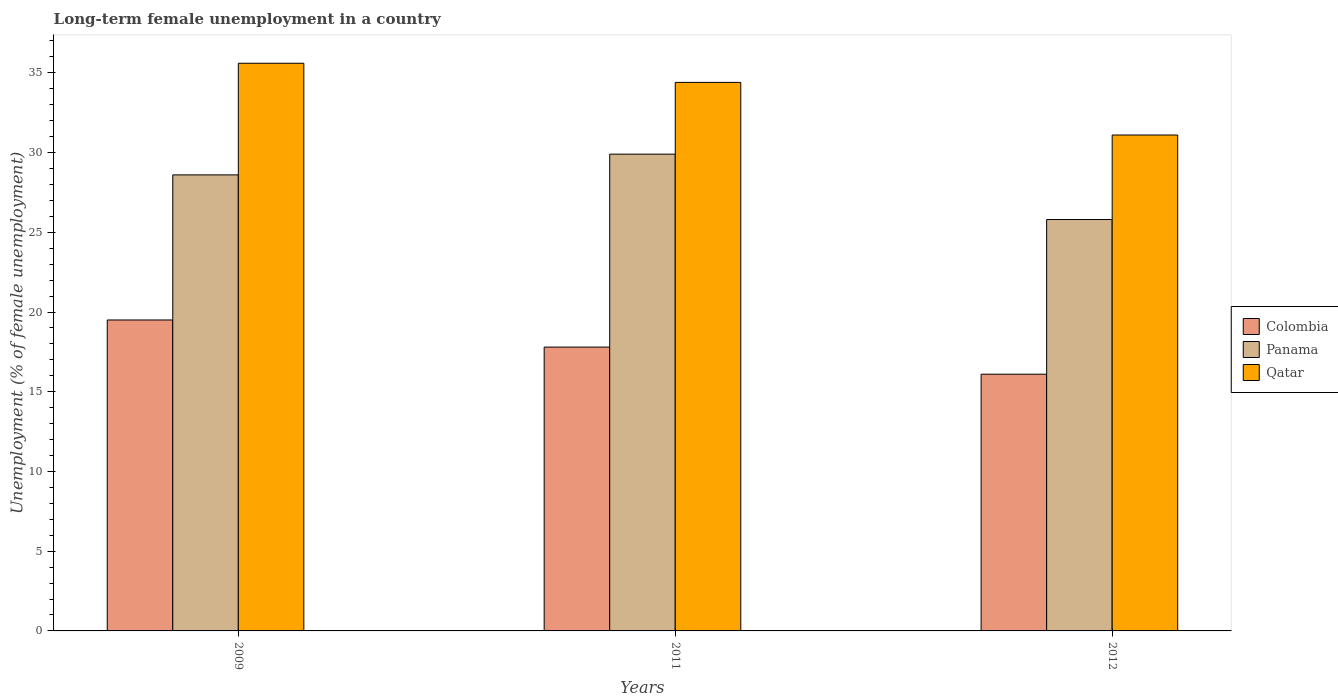How many different coloured bars are there?
Your answer should be compact. 3. How many bars are there on the 2nd tick from the left?
Offer a very short reply. 3. What is the label of the 1st group of bars from the left?
Your answer should be very brief. 2009. What is the percentage of long-term unemployed female population in Colombia in 2011?
Provide a succinct answer. 17.8. Across all years, what is the minimum percentage of long-term unemployed female population in Panama?
Your answer should be very brief. 25.8. In which year was the percentage of long-term unemployed female population in Qatar maximum?
Your response must be concise. 2009. In which year was the percentage of long-term unemployed female population in Panama minimum?
Provide a short and direct response. 2012. What is the total percentage of long-term unemployed female population in Colombia in the graph?
Offer a terse response. 53.4. What is the difference between the percentage of long-term unemployed female population in Qatar in 2009 and that in 2011?
Provide a short and direct response. 1.2. What is the average percentage of long-term unemployed female population in Colombia per year?
Provide a short and direct response. 17.8. In the year 2012, what is the difference between the percentage of long-term unemployed female population in Colombia and percentage of long-term unemployed female population in Panama?
Your answer should be compact. -9.7. What is the ratio of the percentage of long-term unemployed female population in Qatar in 2011 to that in 2012?
Offer a terse response. 1.11. Is the difference between the percentage of long-term unemployed female population in Colombia in 2011 and 2012 greater than the difference between the percentage of long-term unemployed female population in Panama in 2011 and 2012?
Make the answer very short. No. What is the difference between the highest and the second highest percentage of long-term unemployed female population in Qatar?
Ensure brevity in your answer.  1.2. What is the difference between the highest and the lowest percentage of long-term unemployed female population in Colombia?
Make the answer very short. 3.4. Is the sum of the percentage of long-term unemployed female population in Qatar in 2009 and 2011 greater than the maximum percentage of long-term unemployed female population in Colombia across all years?
Give a very brief answer. Yes. What does the 1st bar from the left in 2009 represents?
Provide a short and direct response. Colombia. What does the 2nd bar from the right in 2012 represents?
Keep it short and to the point. Panama. Is it the case that in every year, the sum of the percentage of long-term unemployed female population in Panama and percentage of long-term unemployed female population in Qatar is greater than the percentage of long-term unemployed female population in Colombia?
Ensure brevity in your answer.  Yes. Are all the bars in the graph horizontal?
Ensure brevity in your answer.  No. How many years are there in the graph?
Give a very brief answer. 3. What is the difference between two consecutive major ticks on the Y-axis?
Make the answer very short. 5. Are the values on the major ticks of Y-axis written in scientific E-notation?
Offer a terse response. No. Where does the legend appear in the graph?
Offer a terse response. Center right. How many legend labels are there?
Make the answer very short. 3. How are the legend labels stacked?
Your response must be concise. Vertical. What is the title of the graph?
Your answer should be very brief. Long-term female unemployment in a country. What is the label or title of the X-axis?
Offer a very short reply. Years. What is the label or title of the Y-axis?
Your answer should be very brief. Unemployment (% of female unemployment). What is the Unemployment (% of female unemployment) in Colombia in 2009?
Provide a succinct answer. 19.5. What is the Unemployment (% of female unemployment) in Panama in 2009?
Provide a short and direct response. 28.6. What is the Unemployment (% of female unemployment) in Qatar in 2009?
Offer a very short reply. 35.6. What is the Unemployment (% of female unemployment) of Colombia in 2011?
Offer a very short reply. 17.8. What is the Unemployment (% of female unemployment) in Panama in 2011?
Keep it short and to the point. 29.9. What is the Unemployment (% of female unemployment) in Qatar in 2011?
Offer a very short reply. 34.4. What is the Unemployment (% of female unemployment) in Colombia in 2012?
Your response must be concise. 16.1. What is the Unemployment (% of female unemployment) of Panama in 2012?
Provide a short and direct response. 25.8. What is the Unemployment (% of female unemployment) in Qatar in 2012?
Your answer should be very brief. 31.1. Across all years, what is the maximum Unemployment (% of female unemployment) of Colombia?
Your answer should be very brief. 19.5. Across all years, what is the maximum Unemployment (% of female unemployment) in Panama?
Provide a short and direct response. 29.9. Across all years, what is the maximum Unemployment (% of female unemployment) in Qatar?
Ensure brevity in your answer.  35.6. Across all years, what is the minimum Unemployment (% of female unemployment) of Colombia?
Make the answer very short. 16.1. Across all years, what is the minimum Unemployment (% of female unemployment) in Panama?
Your answer should be very brief. 25.8. Across all years, what is the minimum Unemployment (% of female unemployment) of Qatar?
Provide a short and direct response. 31.1. What is the total Unemployment (% of female unemployment) of Colombia in the graph?
Ensure brevity in your answer.  53.4. What is the total Unemployment (% of female unemployment) in Panama in the graph?
Your response must be concise. 84.3. What is the total Unemployment (% of female unemployment) in Qatar in the graph?
Make the answer very short. 101.1. What is the difference between the Unemployment (% of female unemployment) of Colombia in 2009 and that in 2011?
Provide a succinct answer. 1.7. What is the difference between the Unemployment (% of female unemployment) of Panama in 2009 and that in 2011?
Your response must be concise. -1.3. What is the difference between the Unemployment (% of female unemployment) of Panama in 2009 and that in 2012?
Your response must be concise. 2.8. What is the difference between the Unemployment (% of female unemployment) in Qatar in 2009 and that in 2012?
Your response must be concise. 4.5. What is the difference between the Unemployment (% of female unemployment) in Colombia in 2011 and that in 2012?
Keep it short and to the point. 1.7. What is the difference between the Unemployment (% of female unemployment) in Panama in 2011 and that in 2012?
Your answer should be compact. 4.1. What is the difference between the Unemployment (% of female unemployment) in Colombia in 2009 and the Unemployment (% of female unemployment) in Qatar in 2011?
Provide a succinct answer. -14.9. What is the difference between the Unemployment (% of female unemployment) of Colombia in 2009 and the Unemployment (% of female unemployment) of Panama in 2012?
Give a very brief answer. -6.3. What is the difference between the Unemployment (% of female unemployment) of Colombia in 2011 and the Unemployment (% of female unemployment) of Panama in 2012?
Make the answer very short. -8. What is the difference between the Unemployment (% of female unemployment) of Panama in 2011 and the Unemployment (% of female unemployment) of Qatar in 2012?
Provide a short and direct response. -1.2. What is the average Unemployment (% of female unemployment) in Panama per year?
Ensure brevity in your answer.  28.1. What is the average Unemployment (% of female unemployment) of Qatar per year?
Provide a succinct answer. 33.7. In the year 2009, what is the difference between the Unemployment (% of female unemployment) in Colombia and Unemployment (% of female unemployment) in Qatar?
Your answer should be very brief. -16.1. In the year 2009, what is the difference between the Unemployment (% of female unemployment) of Panama and Unemployment (% of female unemployment) of Qatar?
Your answer should be compact. -7. In the year 2011, what is the difference between the Unemployment (% of female unemployment) in Colombia and Unemployment (% of female unemployment) in Panama?
Make the answer very short. -12.1. In the year 2011, what is the difference between the Unemployment (% of female unemployment) of Colombia and Unemployment (% of female unemployment) of Qatar?
Provide a short and direct response. -16.6. In the year 2011, what is the difference between the Unemployment (% of female unemployment) in Panama and Unemployment (% of female unemployment) in Qatar?
Provide a short and direct response. -4.5. What is the ratio of the Unemployment (% of female unemployment) of Colombia in 2009 to that in 2011?
Your answer should be very brief. 1.1. What is the ratio of the Unemployment (% of female unemployment) in Panama in 2009 to that in 2011?
Give a very brief answer. 0.96. What is the ratio of the Unemployment (% of female unemployment) in Qatar in 2009 to that in 2011?
Your answer should be very brief. 1.03. What is the ratio of the Unemployment (% of female unemployment) in Colombia in 2009 to that in 2012?
Make the answer very short. 1.21. What is the ratio of the Unemployment (% of female unemployment) in Panama in 2009 to that in 2012?
Make the answer very short. 1.11. What is the ratio of the Unemployment (% of female unemployment) in Qatar in 2009 to that in 2012?
Your answer should be compact. 1.14. What is the ratio of the Unemployment (% of female unemployment) of Colombia in 2011 to that in 2012?
Give a very brief answer. 1.11. What is the ratio of the Unemployment (% of female unemployment) of Panama in 2011 to that in 2012?
Your response must be concise. 1.16. What is the ratio of the Unemployment (% of female unemployment) of Qatar in 2011 to that in 2012?
Keep it short and to the point. 1.11. What is the difference between the highest and the second highest Unemployment (% of female unemployment) of Panama?
Your response must be concise. 1.3. What is the difference between the highest and the second highest Unemployment (% of female unemployment) of Qatar?
Give a very brief answer. 1.2. 